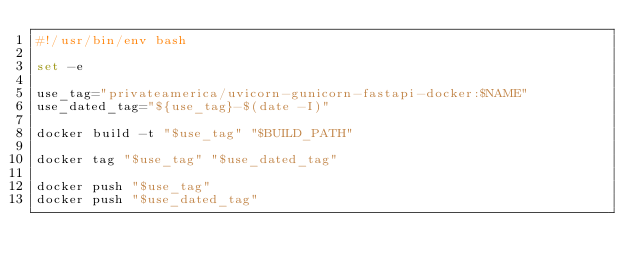<code> <loc_0><loc_0><loc_500><loc_500><_Bash_>#!/usr/bin/env bash

set -e

use_tag="privateamerica/uvicorn-gunicorn-fastapi-docker:$NAME"
use_dated_tag="${use_tag}-$(date -I)"

docker build -t "$use_tag" "$BUILD_PATH"

docker tag "$use_tag" "$use_dated_tag"

docker push "$use_tag"
docker push "$use_dated_tag"
</code> 